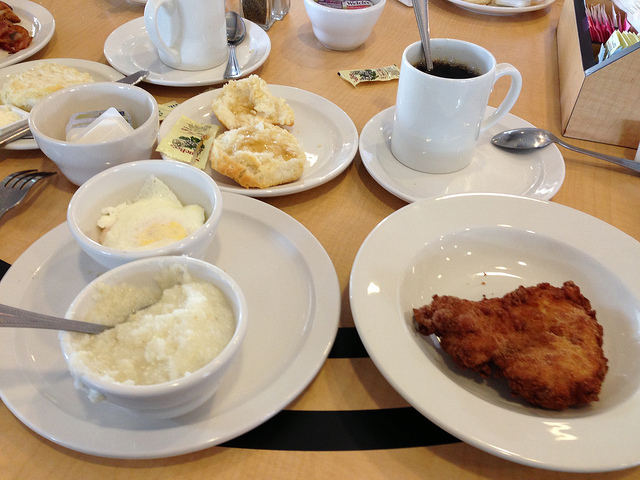<image>Is there butter anywhere? I don't know if there's butter in the image. What utensils are on the plates? I am not sure about the utensils on the plates. It can be spoons, forks, or knife. Is there butter anywhere? There is butter somewhere in the image. What utensils are on the plates? I am not sure what utensils are on the plates. It can be seen spoons and forks, spoons, or none. 